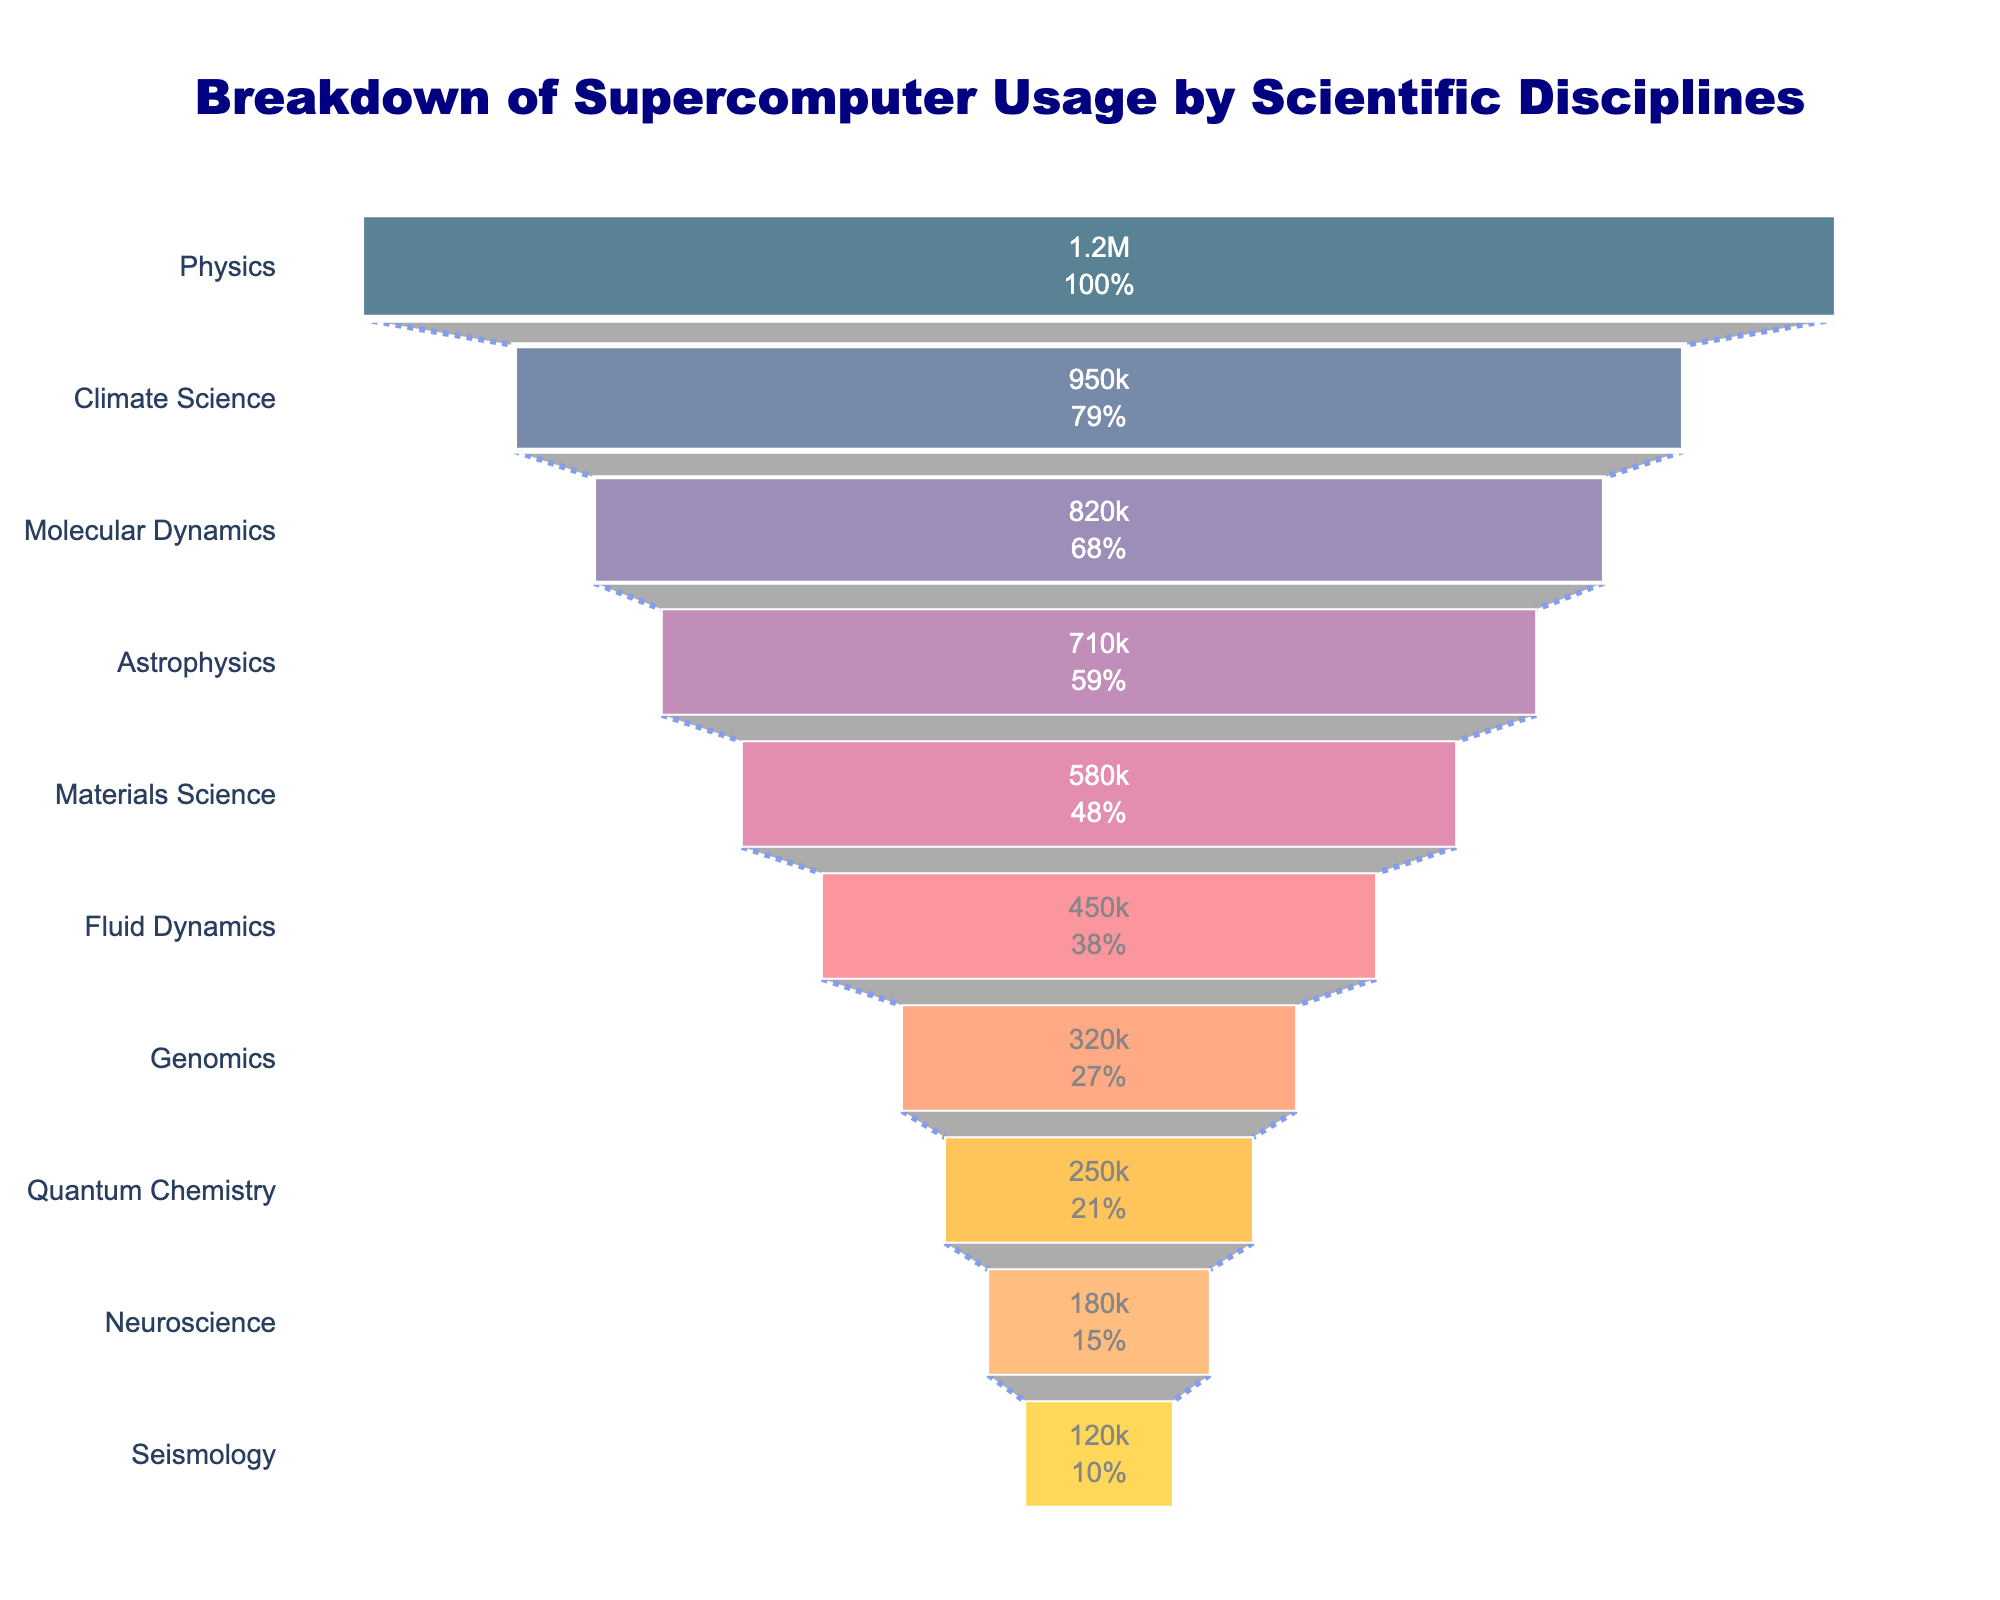What is the discipline with the highest usage of supercomputing hours? The figure shows a funnel chart with the disciplines listed in descending order of computing hours. The top discipline, indicated by the widest section of the funnel, is Physics.
Answer: Physics Which discipline uses the least computing hours? The figure shows a funnel chart with disciplines listed in descending order of computing hours. The narrowest section at the bottom represents the discipline with the least usage, which is Seismology.
Answer: Seismology What is the total number of scientific disciplines represented in the chart? The funnel chart lists the disciplines along the y-axis. Counting these entries gives 10 disciplines.
Answer: 10 How many more computing hours does Physics use compared to Climate Science? Physics is listed at 1,200,000 computing hours, and Climate Science at 950,000 computing hours. The difference is 1,200,000 - 950,000 = 250,000 computing hours.
Answer: 250,000 Which scientific disciplines use more computing hours than Molecular Dynamics but less than Physics? The disciplines listed between Physics (1,200,000) and Molecular Dynamics (820,000) are Climate Science (950,000).
Answer: Climate Science What percentage of the initial computing hours does Climate Science represent? According to the funnel chart, Climate Science uses 950,000 hours. Physics, at the start, uses 1,200,000 hours. The percentage is (950,000 / 1,200,000) * 100 = 79.17%.
Answer: 79.17% What is the combined total of computing hours used by Astrophysics and Materials Science? Astrophysics uses 710,000 hours, and Materials Science uses 580,000 hours. Their combined total is 710,000 + 580,000 = 1,290,000 hours.
Answer: 1,290,000 How does the usage of Fluid Dynamics compare to Genomics? Fluid Dynamics uses 450,000 hours, while Genomics uses 320,000 hours. Fluid Dynamics uses more supercomputing hours.
Answer: Fluid Dynamics uses more Among Quantum Chemistry, Neuroscience, and Seismology, which one uses the most computing hours? From the data, Quantum Chemistry uses 250,000 hours, Neuroscience uses 180,000 hours, and Seismology uses 120,000 hours. Quantum Chemistry has the highest usage among the three.
Answer: Quantum Chemistry 